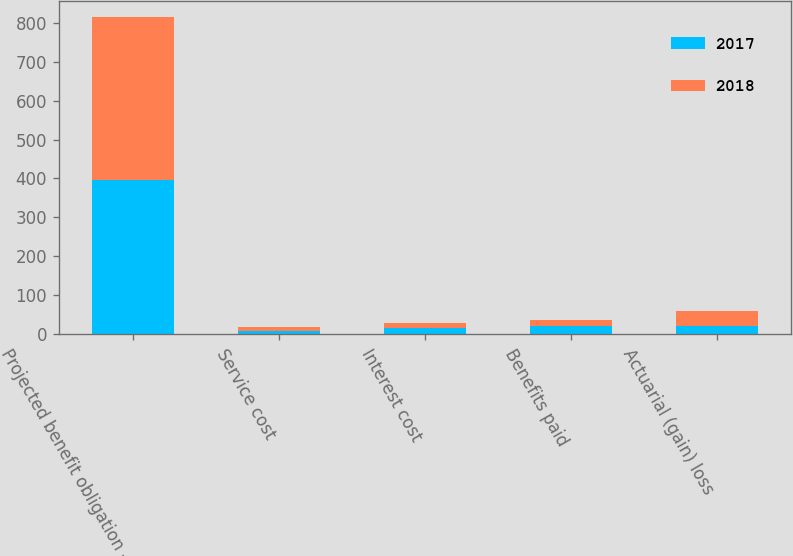<chart> <loc_0><loc_0><loc_500><loc_500><stacked_bar_chart><ecel><fcel>Projected benefit obligation -<fcel>Service cost<fcel>Interest cost<fcel>Benefits paid<fcel>Actuarial (gain) loss<nl><fcel>2017<fcel>396<fcel>8<fcel>14.2<fcel>20.3<fcel>21.1<nl><fcel>2018<fcel>420.7<fcel>8.7<fcel>14<fcel>14.9<fcel>36.9<nl></chart> 